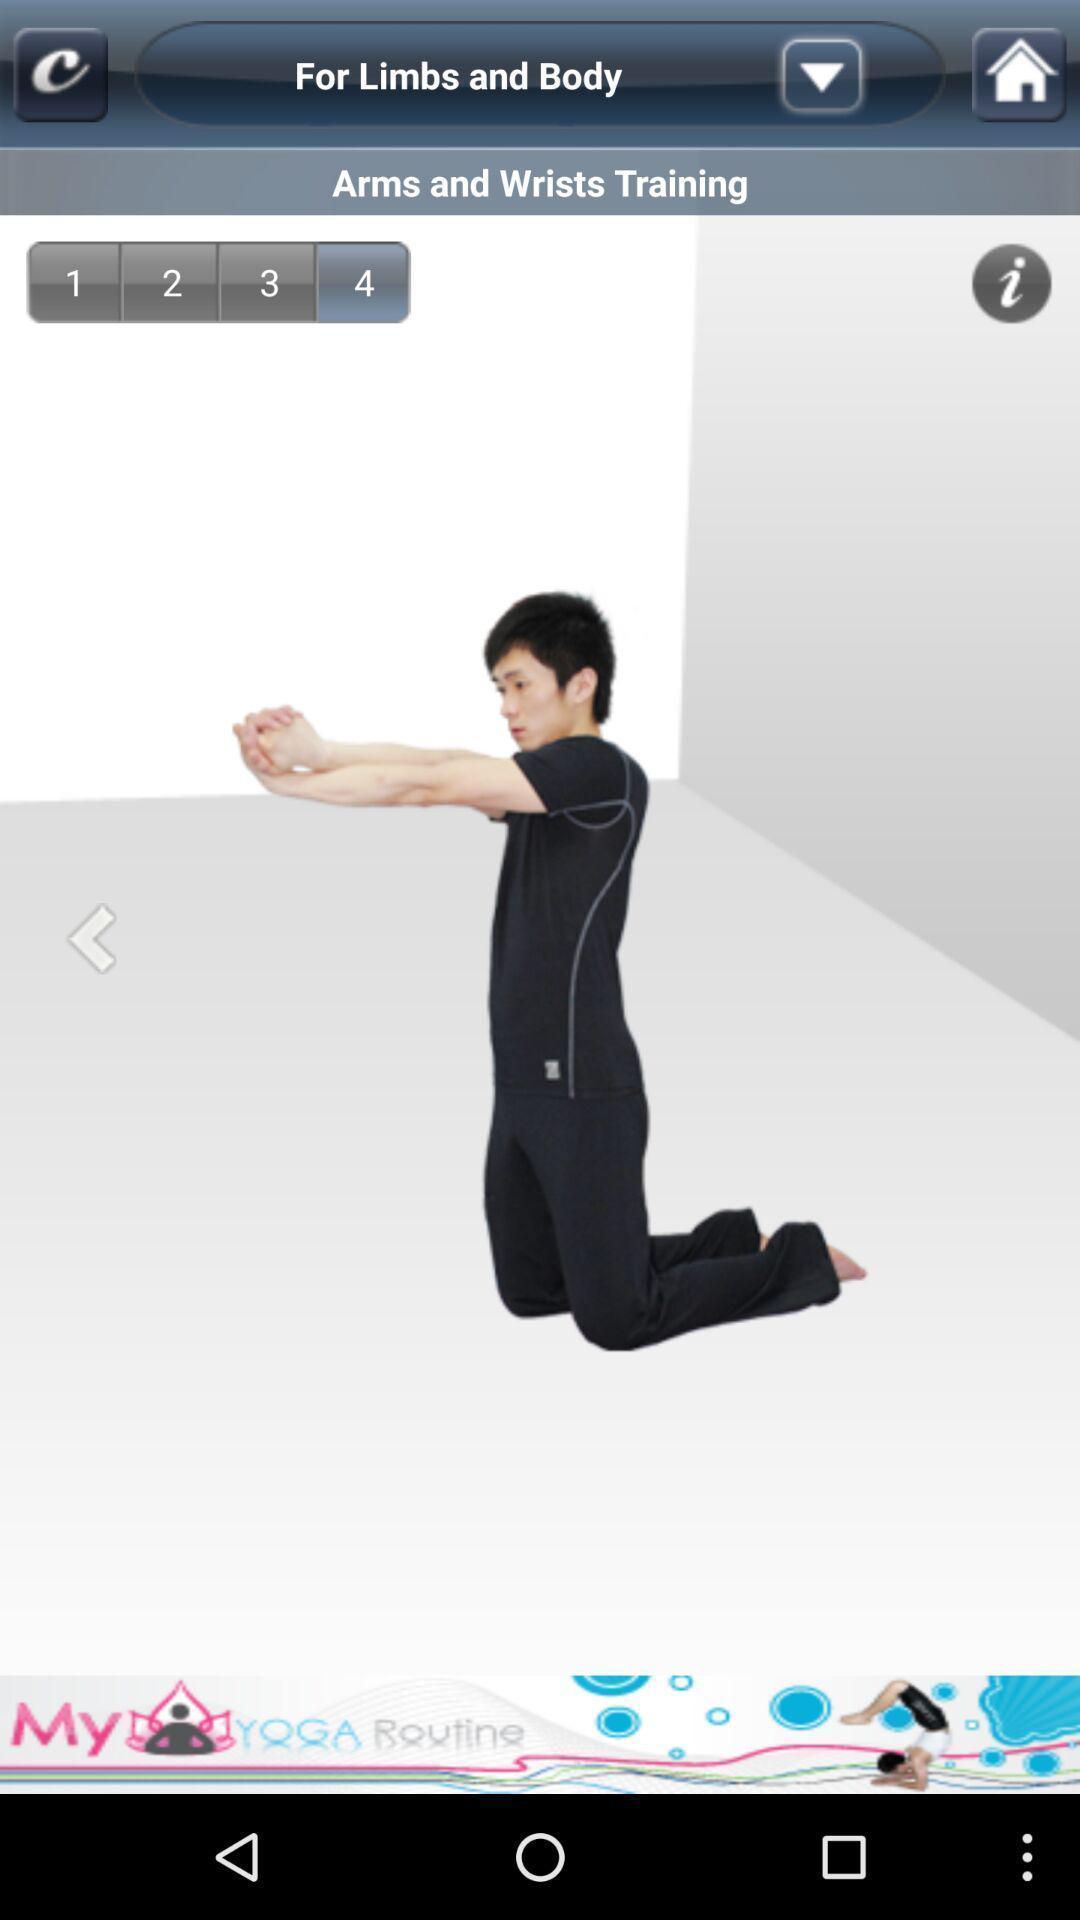Describe the visual elements of this screenshot. Screen showing arms and wrists training. 